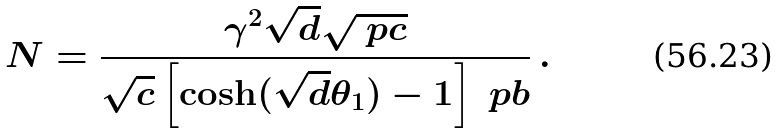<formula> <loc_0><loc_0><loc_500><loc_500>N = \frac { \gamma ^ { 2 } \sqrt { d } \sqrt { \ p c } } { \sqrt { c } \left [ \cosh ( \sqrt { d } \theta _ { 1 } ) - 1 \right ] \ p b } \, .</formula> 